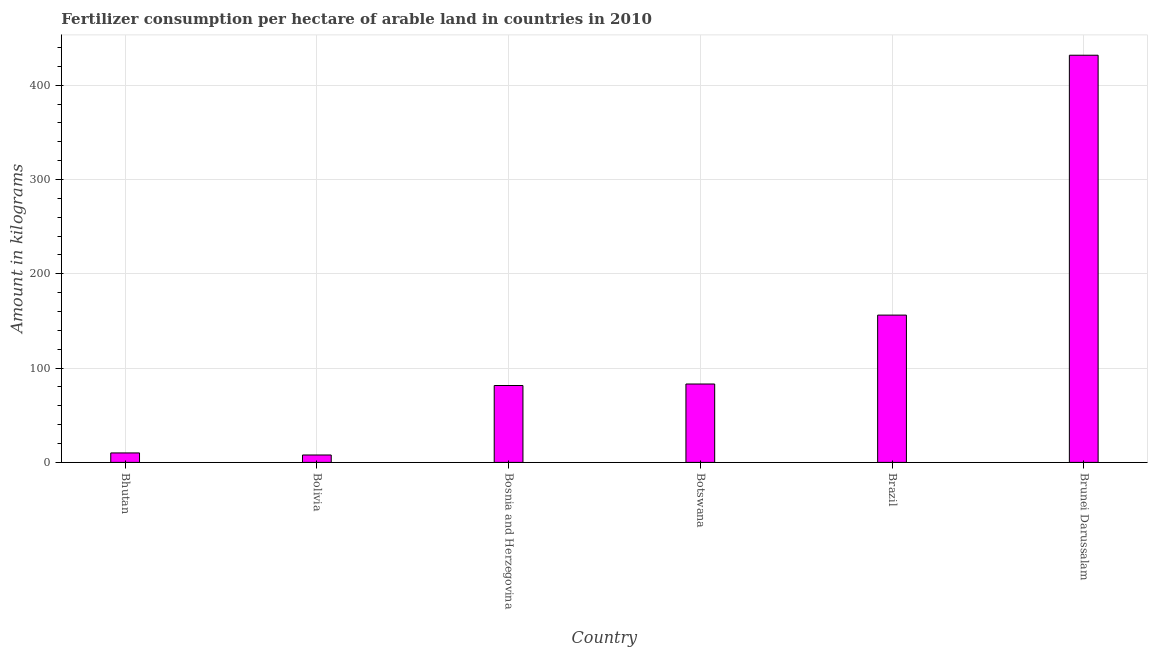Does the graph contain grids?
Your response must be concise. Yes. What is the title of the graph?
Your answer should be compact. Fertilizer consumption per hectare of arable land in countries in 2010 . What is the label or title of the Y-axis?
Provide a succinct answer. Amount in kilograms. What is the amount of fertilizer consumption in Bosnia and Herzegovina?
Your answer should be very brief. 81.53. Across all countries, what is the maximum amount of fertilizer consumption?
Ensure brevity in your answer.  431.75. Across all countries, what is the minimum amount of fertilizer consumption?
Provide a succinct answer. 7.86. In which country was the amount of fertilizer consumption maximum?
Your answer should be very brief. Brunei Darussalam. What is the sum of the amount of fertilizer consumption?
Provide a succinct answer. 770.49. What is the difference between the amount of fertilizer consumption in Bosnia and Herzegovina and Brazil?
Offer a very short reply. -74.66. What is the average amount of fertilizer consumption per country?
Your answer should be very brief. 128.41. What is the median amount of fertilizer consumption?
Your response must be concise. 82.33. What is the ratio of the amount of fertilizer consumption in Botswana to that in Brunei Darussalam?
Keep it short and to the point. 0.19. What is the difference between the highest and the second highest amount of fertilizer consumption?
Your answer should be compact. 275.56. What is the difference between the highest and the lowest amount of fertilizer consumption?
Your answer should be compact. 423.89. In how many countries, is the amount of fertilizer consumption greater than the average amount of fertilizer consumption taken over all countries?
Your response must be concise. 2. How many bars are there?
Keep it short and to the point. 6. What is the Amount in kilograms in Bhutan?
Provide a succinct answer. 10.04. What is the Amount in kilograms in Bolivia?
Provide a succinct answer. 7.86. What is the Amount in kilograms of Bosnia and Herzegovina?
Provide a short and direct response. 81.53. What is the Amount in kilograms of Botswana?
Offer a very short reply. 83.13. What is the Amount in kilograms of Brazil?
Provide a succinct answer. 156.19. What is the Amount in kilograms of Brunei Darussalam?
Keep it short and to the point. 431.75. What is the difference between the Amount in kilograms in Bhutan and Bolivia?
Your answer should be compact. 2.18. What is the difference between the Amount in kilograms in Bhutan and Bosnia and Herzegovina?
Offer a very short reply. -71.49. What is the difference between the Amount in kilograms in Bhutan and Botswana?
Your answer should be very brief. -73.09. What is the difference between the Amount in kilograms in Bhutan and Brazil?
Offer a terse response. -146.15. What is the difference between the Amount in kilograms in Bhutan and Brunei Darussalam?
Ensure brevity in your answer.  -421.71. What is the difference between the Amount in kilograms in Bolivia and Bosnia and Herzegovina?
Keep it short and to the point. -73.67. What is the difference between the Amount in kilograms in Bolivia and Botswana?
Make the answer very short. -75.27. What is the difference between the Amount in kilograms in Bolivia and Brazil?
Your answer should be very brief. -148.33. What is the difference between the Amount in kilograms in Bolivia and Brunei Darussalam?
Make the answer very short. -423.89. What is the difference between the Amount in kilograms in Bosnia and Herzegovina and Botswana?
Your response must be concise. -1.6. What is the difference between the Amount in kilograms in Bosnia and Herzegovina and Brazil?
Provide a succinct answer. -74.66. What is the difference between the Amount in kilograms in Bosnia and Herzegovina and Brunei Darussalam?
Keep it short and to the point. -350.22. What is the difference between the Amount in kilograms in Botswana and Brazil?
Make the answer very short. -73.06. What is the difference between the Amount in kilograms in Botswana and Brunei Darussalam?
Your answer should be compact. -348.62. What is the difference between the Amount in kilograms in Brazil and Brunei Darussalam?
Make the answer very short. -275.56. What is the ratio of the Amount in kilograms in Bhutan to that in Bolivia?
Keep it short and to the point. 1.28. What is the ratio of the Amount in kilograms in Bhutan to that in Bosnia and Herzegovina?
Your answer should be compact. 0.12. What is the ratio of the Amount in kilograms in Bhutan to that in Botswana?
Provide a succinct answer. 0.12. What is the ratio of the Amount in kilograms in Bhutan to that in Brazil?
Make the answer very short. 0.06. What is the ratio of the Amount in kilograms in Bhutan to that in Brunei Darussalam?
Ensure brevity in your answer.  0.02. What is the ratio of the Amount in kilograms in Bolivia to that in Bosnia and Herzegovina?
Offer a very short reply. 0.1. What is the ratio of the Amount in kilograms in Bolivia to that in Botswana?
Make the answer very short. 0.09. What is the ratio of the Amount in kilograms in Bolivia to that in Brazil?
Offer a terse response. 0.05. What is the ratio of the Amount in kilograms in Bolivia to that in Brunei Darussalam?
Make the answer very short. 0.02. What is the ratio of the Amount in kilograms in Bosnia and Herzegovina to that in Brazil?
Offer a terse response. 0.52. What is the ratio of the Amount in kilograms in Bosnia and Herzegovina to that in Brunei Darussalam?
Give a very brief answer. 0.19. What is the ratio of the Amount in kilograms in Botswana to that in Brazil?
Your response must be concise. 0.53. What is the ratio of the Amount in kilograms in Botswana to that in Brunei Darussalam?
Your answer should be very brief. 0.19. What is the ratio of the Amount in kilograms in Brazil to that in Brunei Darussalam?
Offer a terse response. 0.36. 